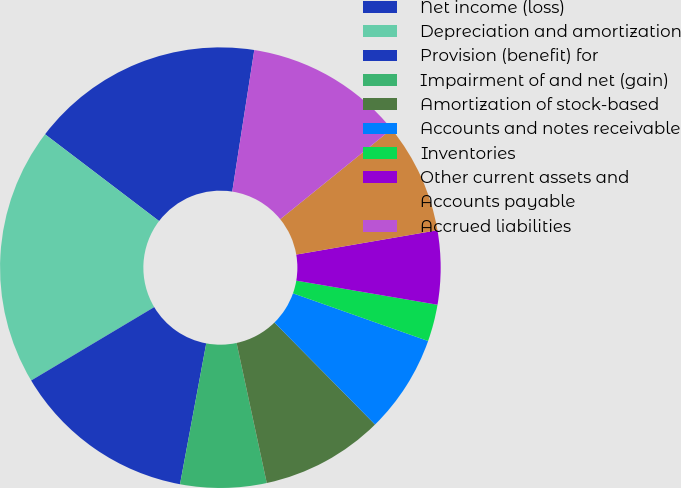Convert chart. <chart><loc_0><loc_0><loc_500><loc_500><pie_chart><fcel>Net income (loss)<fcel>Depreciation and amortization<fcel>Provision (benefit) for<fcel>Impairment of and net (gain)<fcel>Amortization of stock-based<fcel>Accounts and notes receivable<fcel>Inventories<fcel>Other current assets and<fcel>Accounts payable<fcel>Accrued liabilities<nl><fcel>17.11%<fcel>18.91%<fcel>13.51%<fcel>6.31%<fcel>9.01%<fcel>7.21%<fcel>2.71%<fcel>5.41%<fcel>8.11%<fcel>11.71%<nl></chart> 